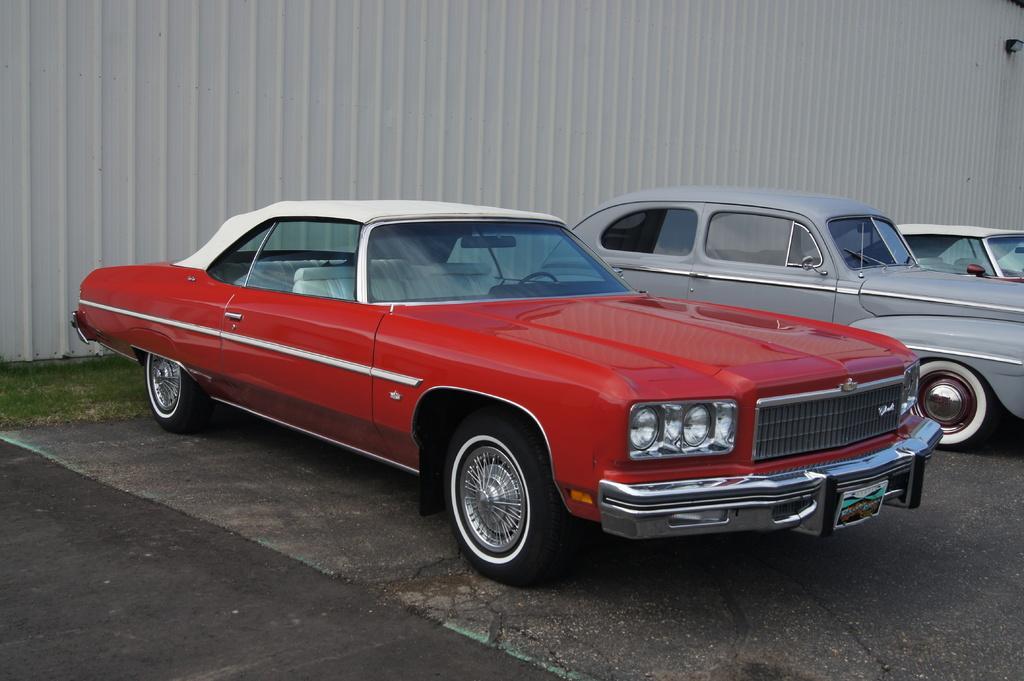Describe this image in one or two sentences. In this picture I can see the vehicles in the parking space. I can see green grass. I can see the roof sheet wall in the background. 